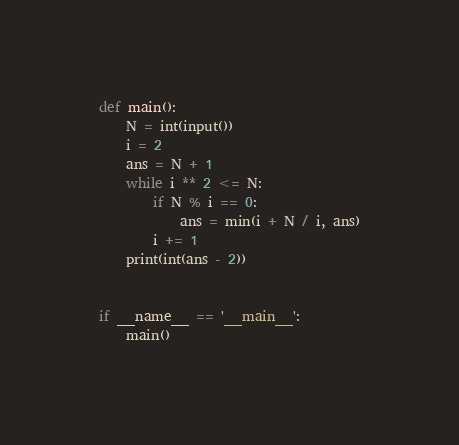Convert code to text. <code><loc_0><loc_0><loc_500><loc_500><_Python_>def main():
    N = int(input())
    i = 2
    ans = N + 1
    while i ** 2 <= N:
        if N % i == 0:
            ans = min(i + N / i, ans)
        i += 1
    print(int(ans - 2))


if __name__ == '__main__':
    main()</code> 